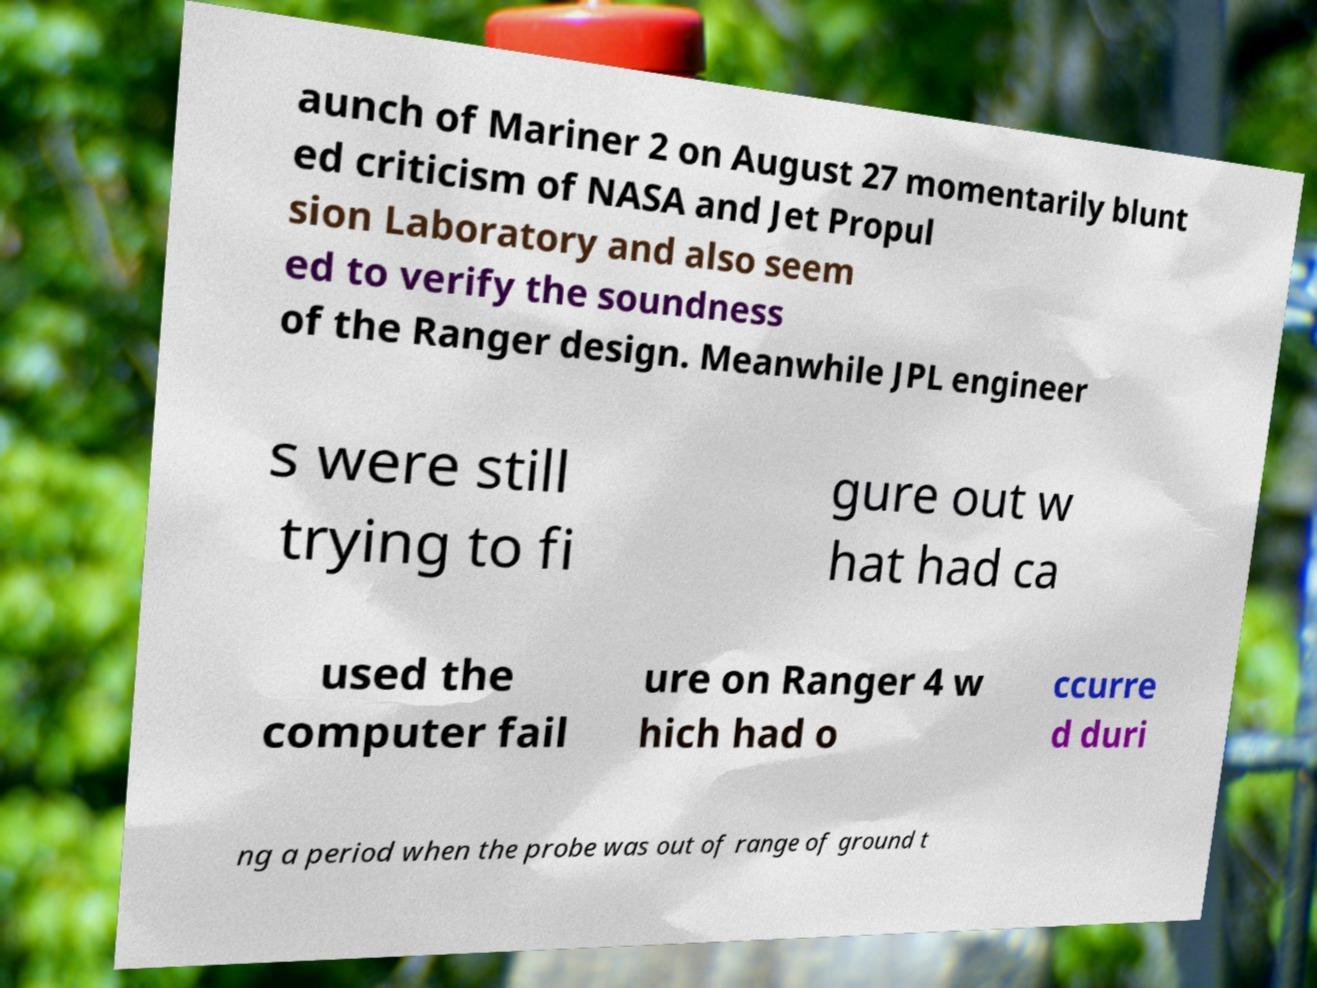For documentation purposes, I need the text within this image transcribed. Could you provide that? aunch of Mariner 2 on August 27 momentarily blunt ed criticism of NASA and Jet Propul sion Laboratory and also seem ed to verify the soundness of the Ranger design. Meanwhile JPL engineer s were still trying to fi gure out w hat had ca used the computer fail ure on Ranger 4 w hich had o ccurre d duri ng a period when the probe was out of range of ground t 